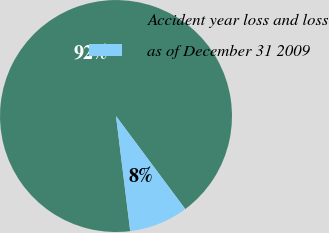<chart> <loc_0><loc_0><loc_500><loc_500><pie_chart><fcel>Accident year loss and loss<fcel>as of December 31 2009<nl><fcel>91.77%<fcel>8.23%<nl></chart> 